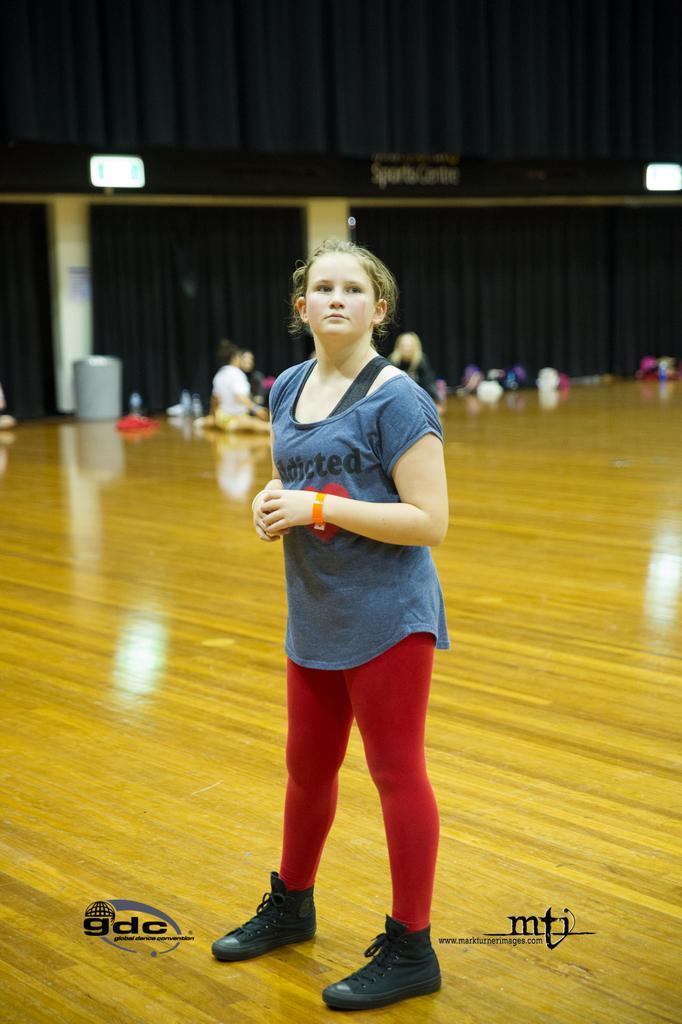Could you give a brief overview of what you see in this image? In this image I can see a person standing on the floor. In the background I can see a curtain. I can see few persons. At the bottom I can see some text. 